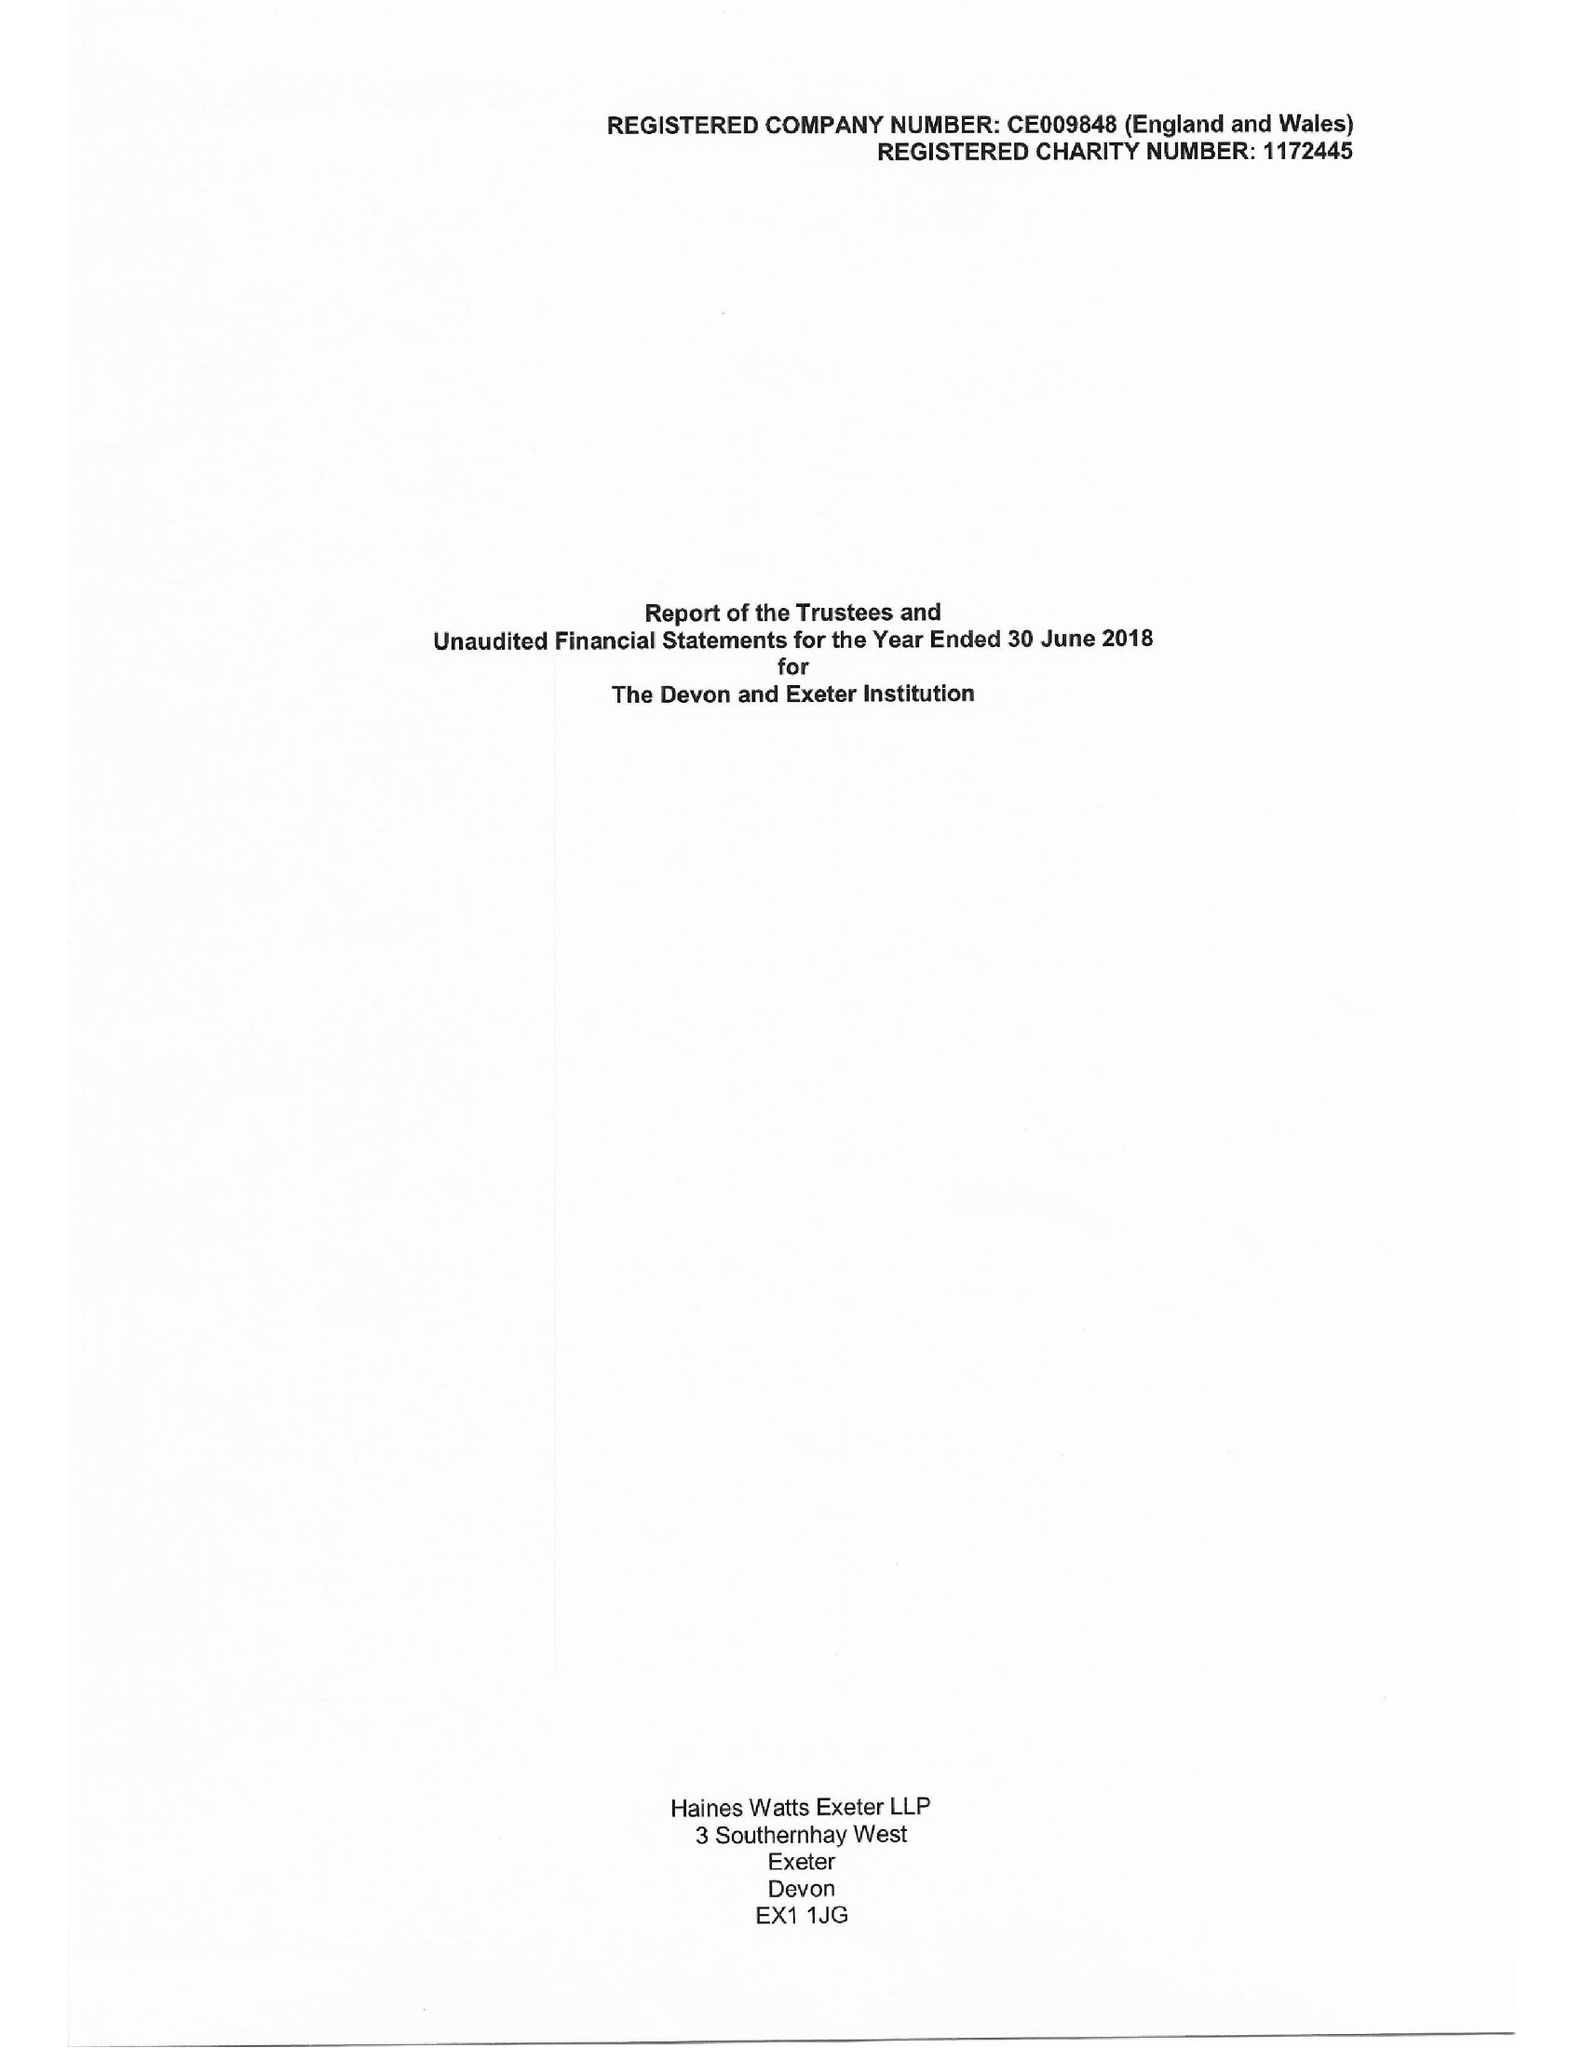What is the value for the report_date?
Answer the question using a single word or phrase. 2018-06-30 